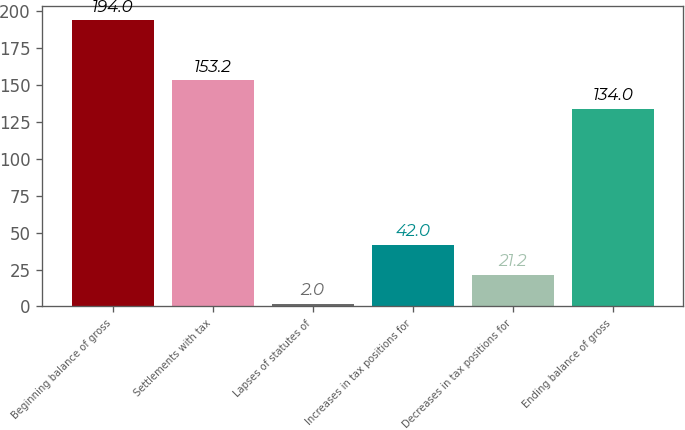<chart> <loc_0><loc_0><loc_500><loc_500><bar_chart><fcel>Beginning balance of gross<fcel>Settlements with tax<fcel>Lapses of statutes of<fcel>Increases in tax positions for<fcel>Decreases in tax positions for<fcel>Ending balance of gross<nl><fcel>194<fcel>153.2<fcel>2<fcel>42<fcel>21.2<fcel>134<nl></chart> 